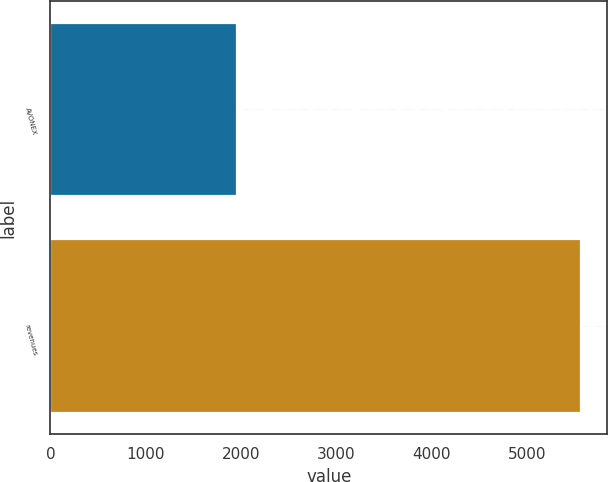Convert chart. <chart><loc_0><loc_0><loc_500><loc_500><bar_chart><fcel>AVONEX<fcel>revenues<nl><fcel>1956.7<fcel>5566.7<nl></chart> 